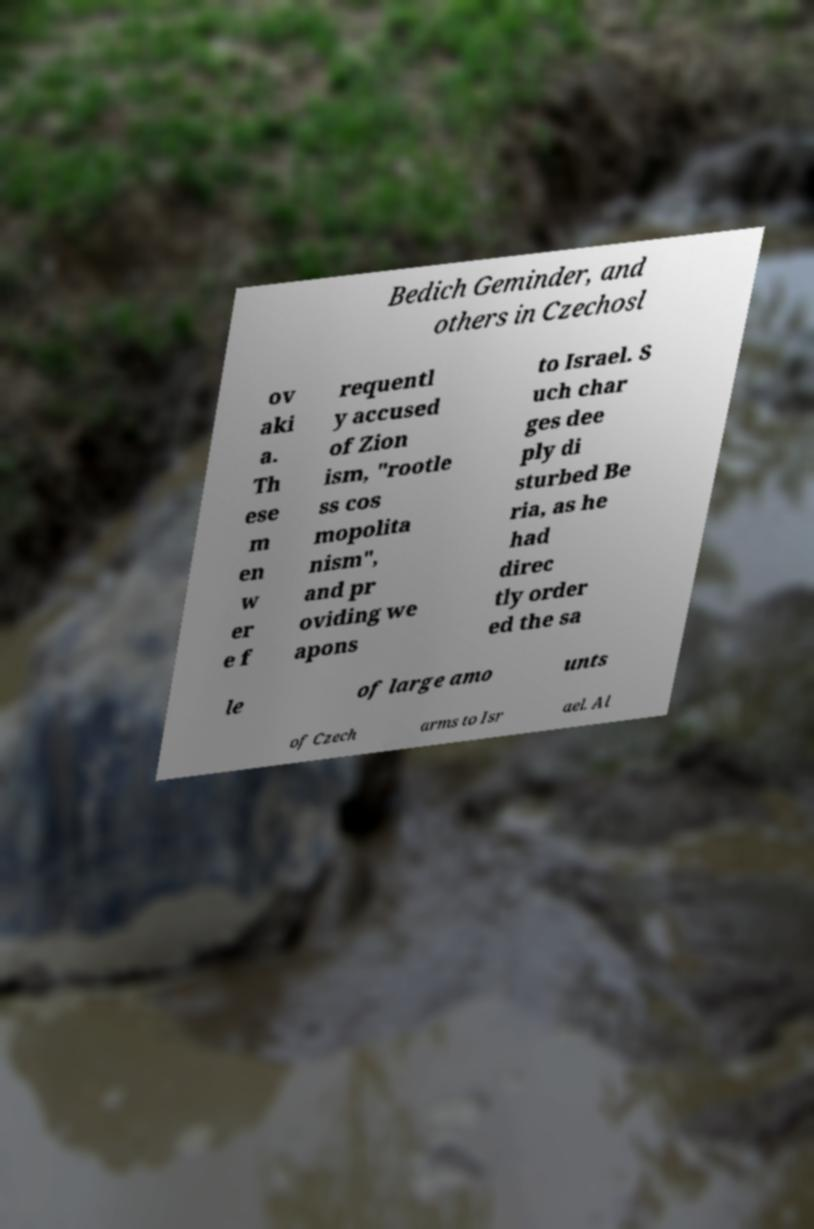For documentation purposes, I need the text within this image transcribed. Could you provide that? Bedich Geminder, and others in Czechosl ov aki a. Th ese m en w er e f requentl y accused of Zion ism, "rootle ss cos mopolita nism", and pr oviding we apons to Israel. S uch char ges dee ply di sturbed Be ria, as he had direc tly order ed the sa le of large amo unts of Czech arms to Isr ael. Al 